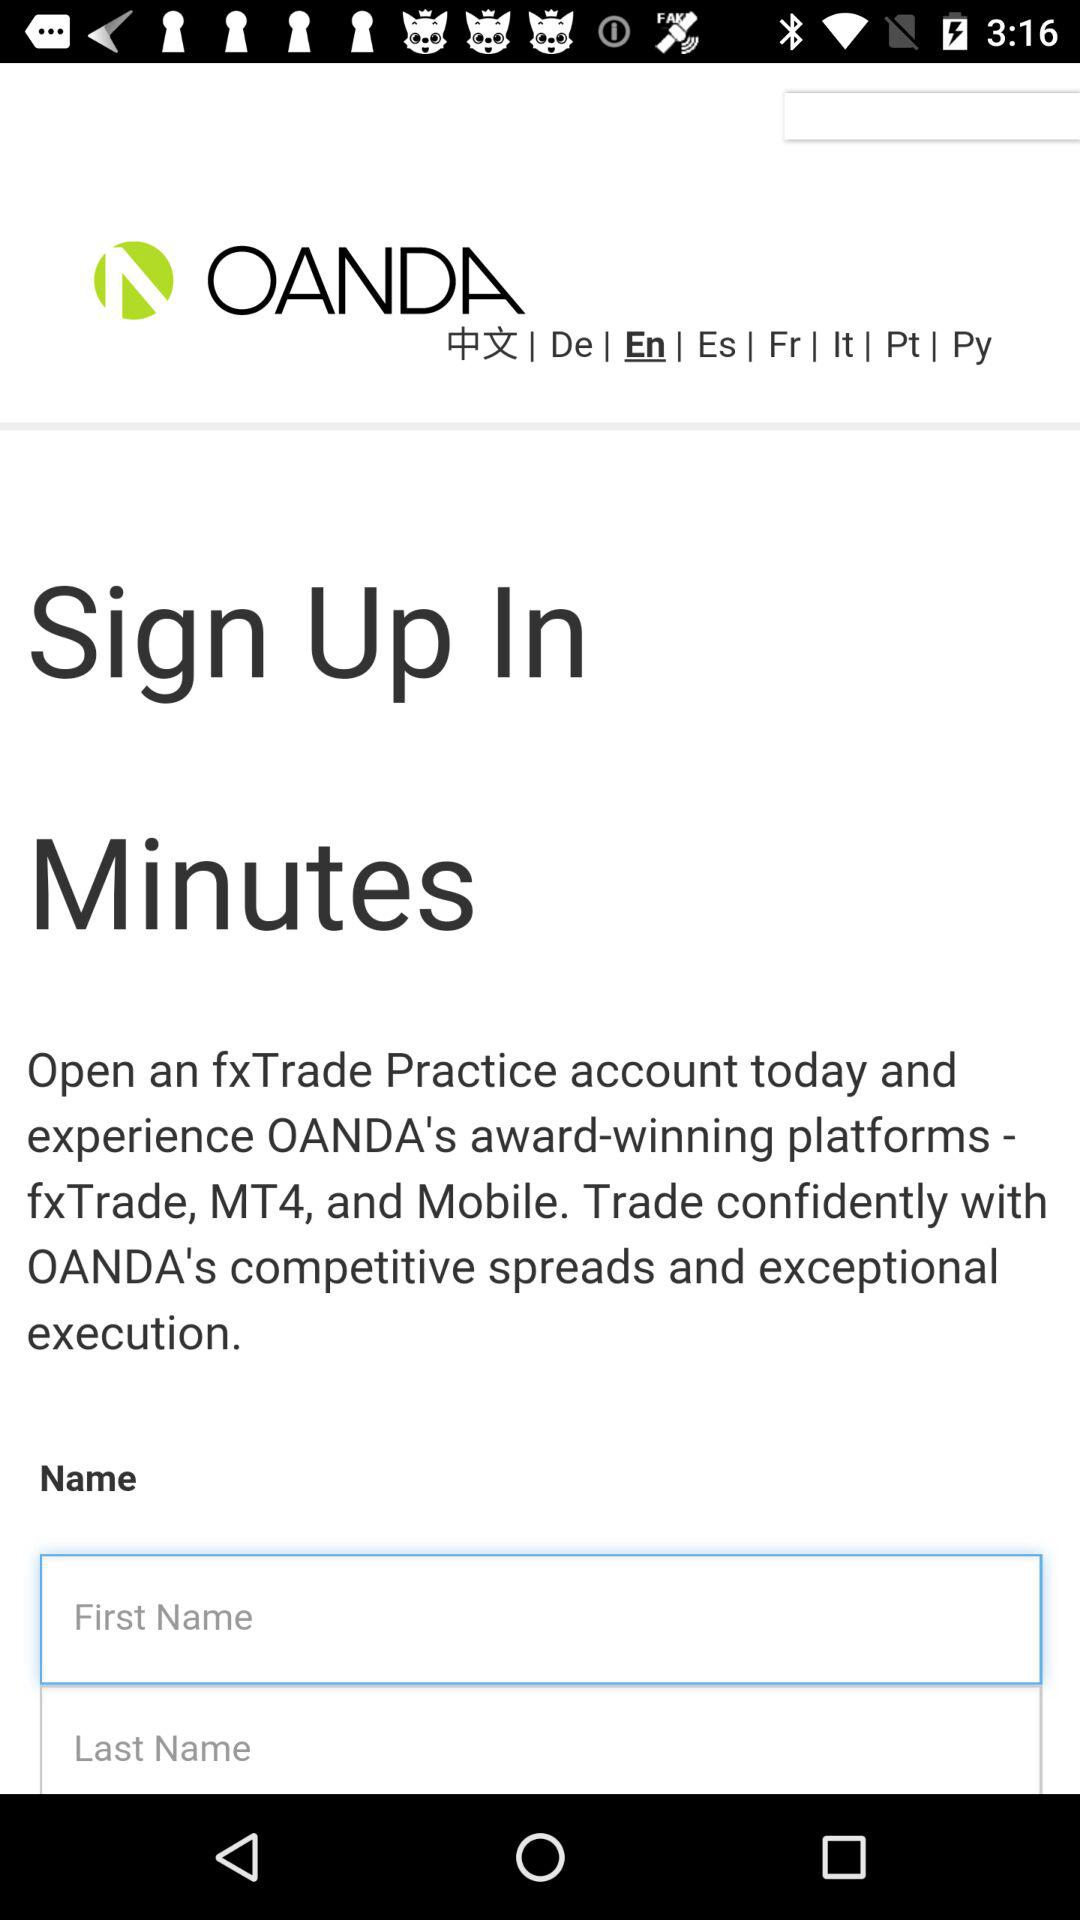What might be the benefits of signing up for an account with this service? Signing up for an account typically offers personalized financial services, access to trading platforms and tools, and the ability to manage investments with supportive customer service. 